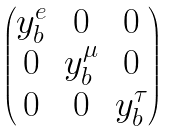Convert formula to latex. <formula><loc_0><loc_0><loc_500><loc_500>\begin{pmatrix} y _ { b } ^ { e } & 0 & 0 \\ 0 & y _ { b } ^ { \mu } & 0 \\ 0 & 0 & y _ { b } ^ { \tau } \end{pmatrix}</formula> 